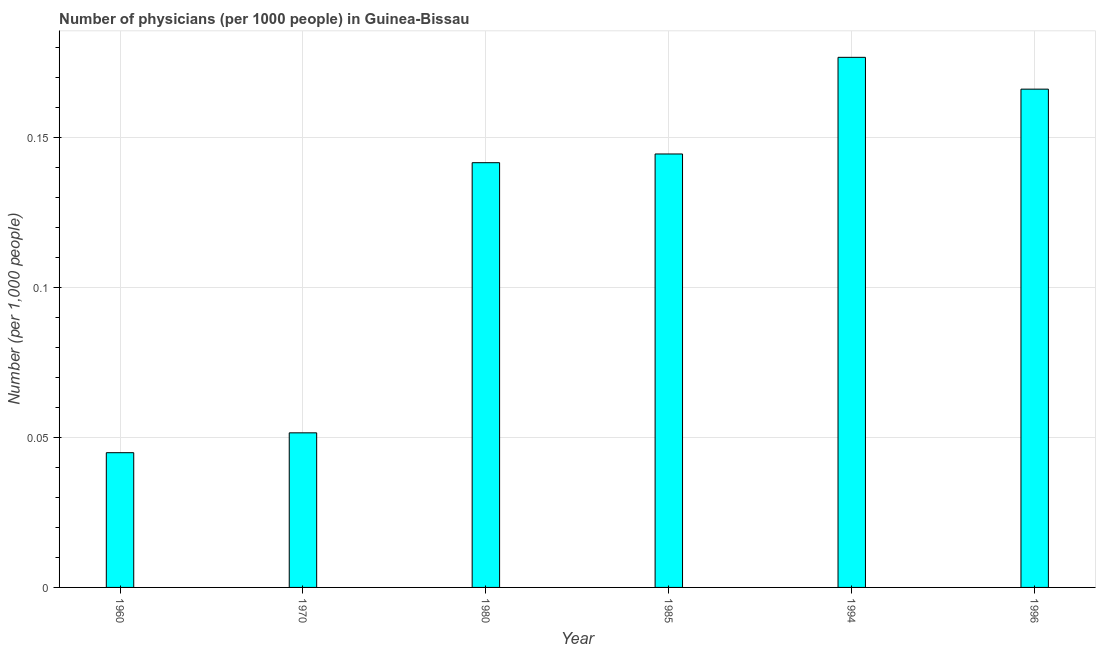What is the title of the graph?
Your answer should be compact. Number of physicians (per 1000 people) in Guinea-Bissau. What is the label or title of the Y-axis?
Offer a terse response. Number (per 1,0 people). What is the number of physicians in 1960?
Keep it short and to the point. 0.04. Across all years, what is the maximum number of physicians?
Ensure brevity in your answer.  0.18. Across all years, what is the minimum number of physicians?
Offer a terse response. 0.04. In which year was the number of physicians maximum?
Provide a succinct answer. 1994. In which year was the number of physicians minimum?
Give a very brief answer. 1960. What is the sum of the number of physicians?
Provide a succinct answer. 0.72. What is the difference between the number of physicians in 1985 and 1996?
Your response must be concise. -0.02. What is the average number of physicians per year?
Your response must be concise. 0.12. What is the median number of physicians?
Give a very brief answer. 0.14. What is the ratio of the number of physicians in 1960 to that in 1980?
Ensure brevity in your answer.  0.32. Is the number of physicians in 1970 less than that in 1994?
Your response must be concise. Yes. What is the difference between the highest and the second highest number of physicians?
Your answer should be very brief. 0.01. What is the difference between the highest and the lowest number of physicians?
Your answer should be compact. 0.13. How many bars are there?
Your answer should be very brief. 6. How many years are there in the graph?
Make the answer very short. 6. What is the difference between two consecutive major ticks on the Y-axis?
Offer a very short reply. 0.05. What is the Number (per 1,000 people) in 1960?
Offer a very short reply. 0.04. What is the Number (per 1,000 people) of 1970?
Keep it short and to the point. 0.05. What is the Number (per 1,000 people) in 1980?
Offer a very short reply. 0.14. What is the Number (per 1,000 people) in 1985?
Offer a very short reply. 0.14. What is the Number (per 1,000 people) in 1994?
Your answer should be compact. 0.18. What is the Number (per 1,000 people) in 1996?
Offer a very short reply. 0.17. What is the difference between the Number (per 1,000 people) in 1960 and 1970?
Your answer should be very brief. -0.01. What is the difference between the Number (per 1,000 people) in 1960 and 1980?
Your response must be concise. -0.1. What is the difference between the Number (per 1,000 people) in 1960 and 1985?
Ensure brevity in your answer.  -0.1. What is the difference between the Number (per 1,000 people) in 1960 and 1994?
Keep it short and to the point. -0.13. What is the difference between the Number (per 1,000 people) in 1960 and 1996?
Provide a succinct answer. -0.12. What is the difference between the Number (per 1,000 people) in 1970 and 1980?
Your response must be concise. -0.09. What is the difference between the Number (per 1,000 people) in 1970 and 1985?
Give a very brief answer. -0.09. What is the difference between the Number (per 1,000 people) in 1970 and 1994?
Your response must be concise. -0.13. What is the difference between the Number (per 1,000 people) in 1970 and 1996?
Your response must be concise. -0.11. What is the difference between the Number (per 1,000 people) in 1980 and 1985?
Your answer should be compact. -0. What is the difference between the Number (per 1,000 people) in 1980 and 1994?
Provide a succinct answer. -0.04. What is the difference between the Number (per 1,000 people) in 1980 and 1996?
Ensure brevity in your answer.  -0.02. What is the difference between the Number (per 1,000 people) in 1985 and 1994?
Provide a short and direct response. -0.03. What is the difference between the Number (per 1,000 people) in 1985 and 1996?
Your answer should be compact. -0.02. What is the difference between the Number (per 1,000 people) in 1994 and 1996?
Provide a short and direct response. 0.01. What is the ratio of the Number (per 1,000 people) in 1960 to that in 1970?
Your answer should be compact. 0.87. What is the ratio of the Number (per 1,000 people) in 1960 to that in 1980?
Offer a very short reply. 0.32. What is the ratio of the Number (per 1,000 people) in 1960 to that in 1985?
Ensure brevity in your answer.  0.31. What is the ratio of the Number (per 1,000 people) in 1960 to that in 1994?
Offer a terse response. 0.25. What is the ratio of the Number (per 1,000 people) in 1960 to that in 1996?
Your answer should be very brief. 0.27. What is the ratio of the Number (per 1,000 people) in 1970 to that in 1980?
Offer a very short reply. 0.36. What is the ratio of the Number (per 1,000 people) in 1970 to that in 1985?
Offer a very short reply. 0.36. What is the ratio of the Number (per 1,000 people) in 1970 to that in 1994?
Ensure brevity in your answer.  0.29. What is the ratio of the Number (per 1,000 people) in 1970 to that in 1996?
Provide a succinct answer. 0.31. What is the ratio of the Number (per 1,000 people) in 1980 to that in 1994?
Provide a short and direct response. 0.8. What is the ratio of the Number (per 1,000 people) in 1980 to that in 1996?
Offer a terse response. 0.85. What is the ratio of the Number (per 1,000 people) in 1985 to that in 1994?
Your answer should be very brief. 0.82. What is the ratio of the Number (per 1,000 people) in 1985 to that in 1996?
Offer a very short reply. 0.87. What is the ratio of the Number (per 1,000 people) in 1994 to that in 1996?
Make the answer very short. 1.06. 